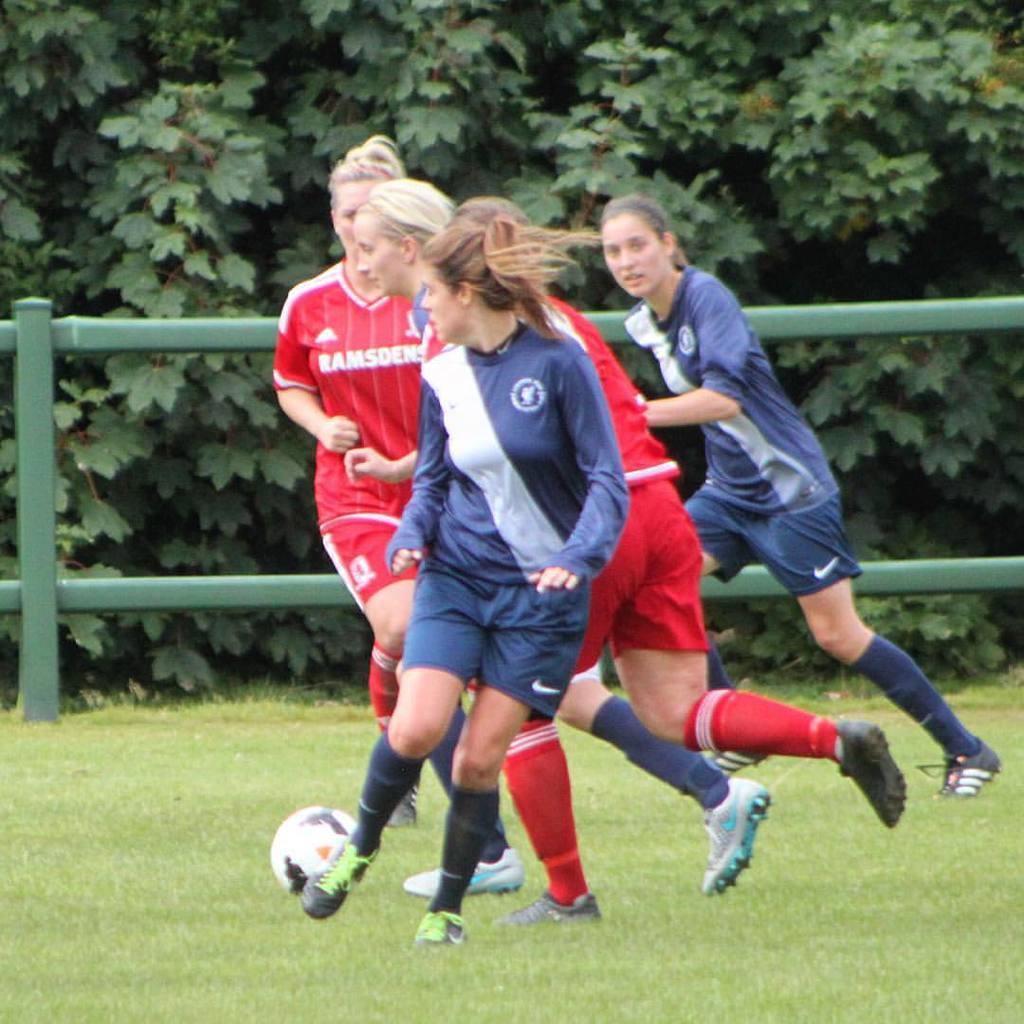How many women are present in the image? There are four women in the image. What are the women doing in the image? The women are running. What object is on the ground in the image? There is a ball on the ground. What can be seen in the background of the image? There are trees and a fence in the background of the image. What is the suggestion made by the sisters in the image? There are no sisters present in the image, and therefore no suggestion can be attributed to them. 